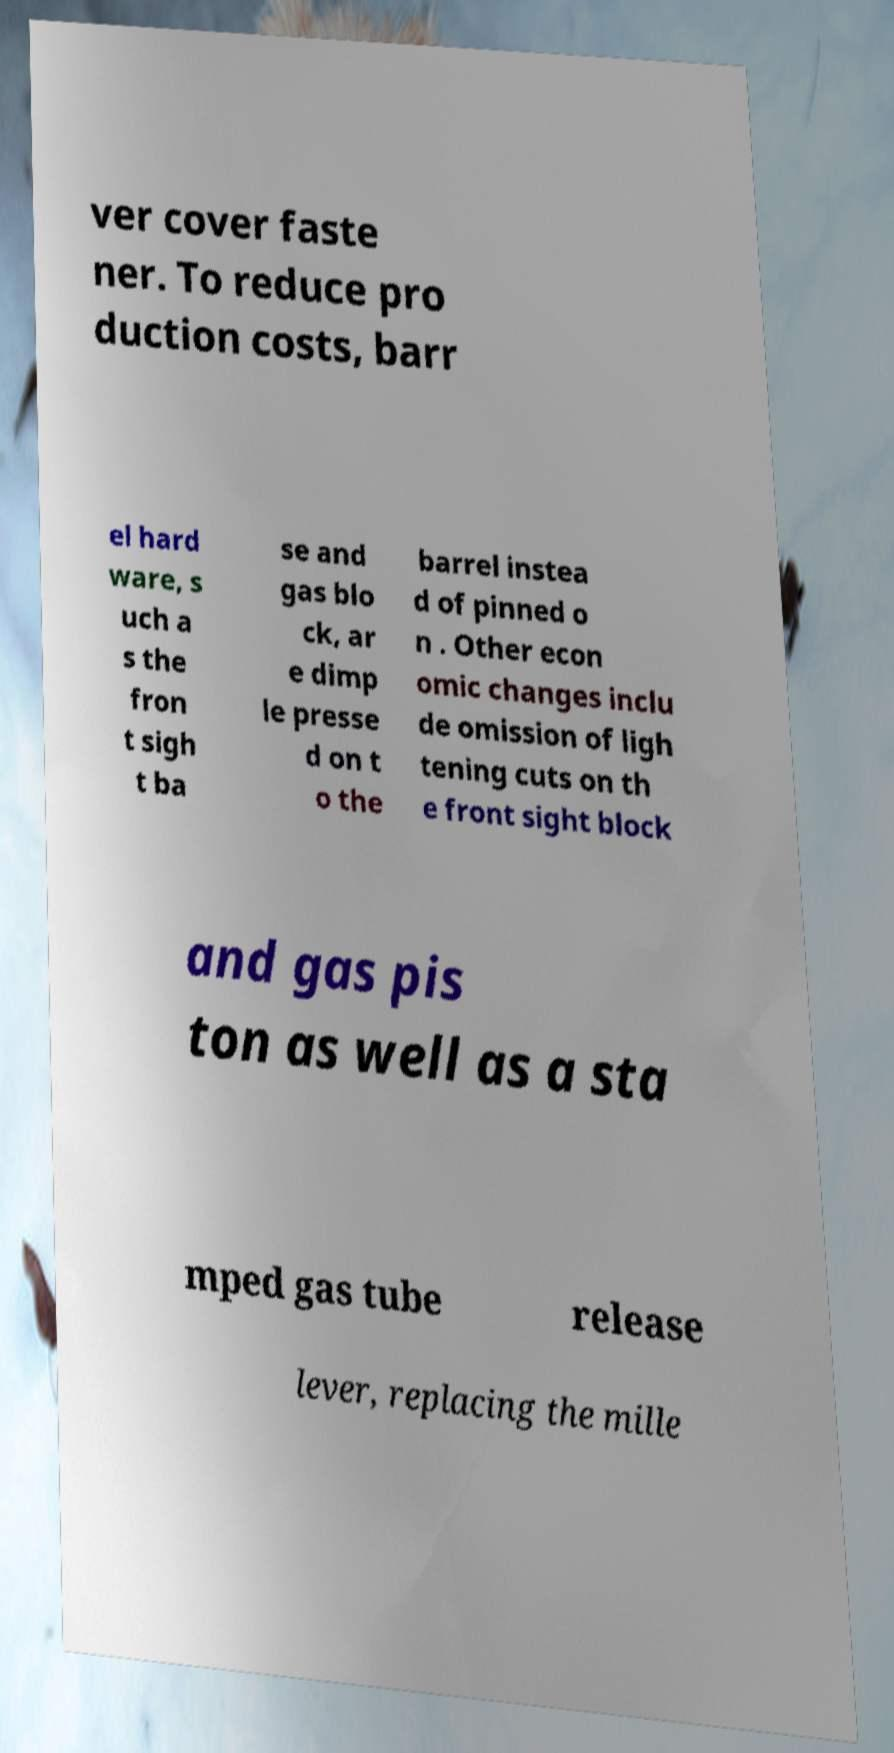I need the written content from this picture converted into text. Can you do that? ver cover faste ner. To reduce pro duction costs, barr el hard ware, s uch a s the fron t sigh t ba se and gas blo ck, ar e dimp le presse d on t o the barrel instea d of pinned o n . Other econ omic changes inclu de omission of ligh tening cuts on th e front sight block and gas pis ton as well as a sta mped gas tube release lever, replacing the mille 